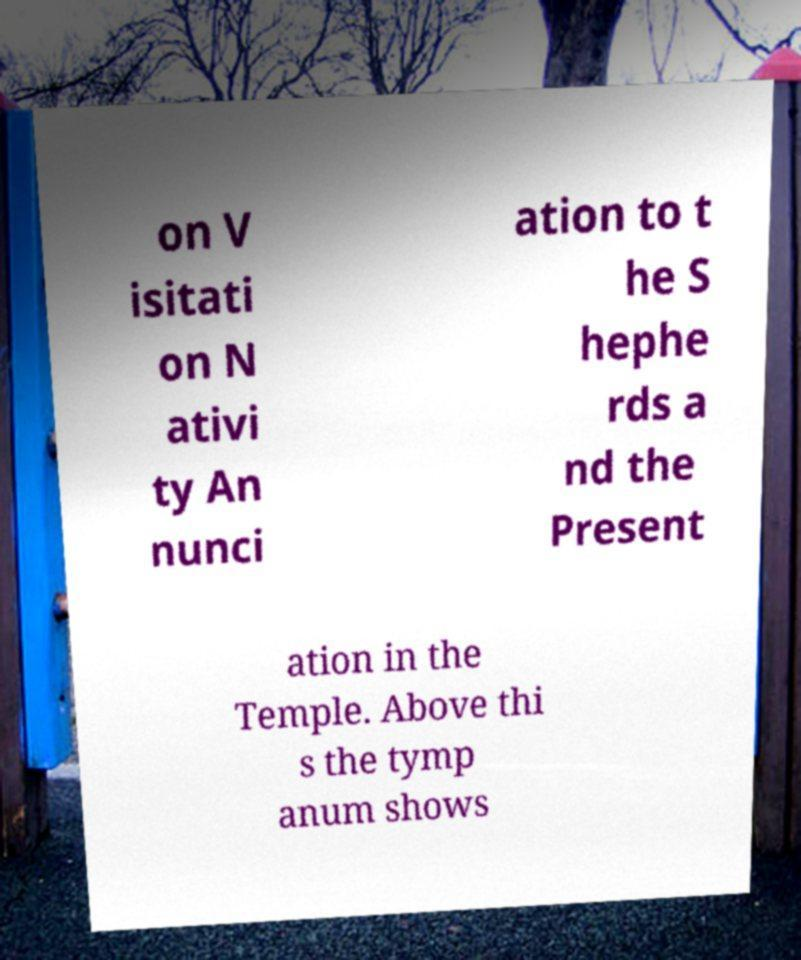What messages or text are displayed in this image? I need them in a readable, typed format. on V isitati on N ativi ty An nunci ation to t he S hephe rds a nd the Present ation in the Temple. Above thi s the tymp anum shows 